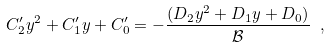<formula> <loc_0><loc_0><loc_500><loc_500>C _ { 2 } ^ { \prime } y ^ { 2 } + C _ { 1 } ^ { \prime } y + C _ { 0 } ^ { \prime } = - \frac { ( D _ { 2 } y ^ { 2 } + D _ { 1 } y + D _ { 0 } ) } { \mathcal { B } } \ ,</formula> 